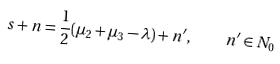<formula> <loc_0><loc_0><loc_500><loc_500>s + n = \frac { 1 } { 2 } ( \mu _ { 2 } + \mu _ { 3 } - \lambda ) + n ^ { \prime } , \quad n ^ { \prime } \in N _ { 0 }</formula> 